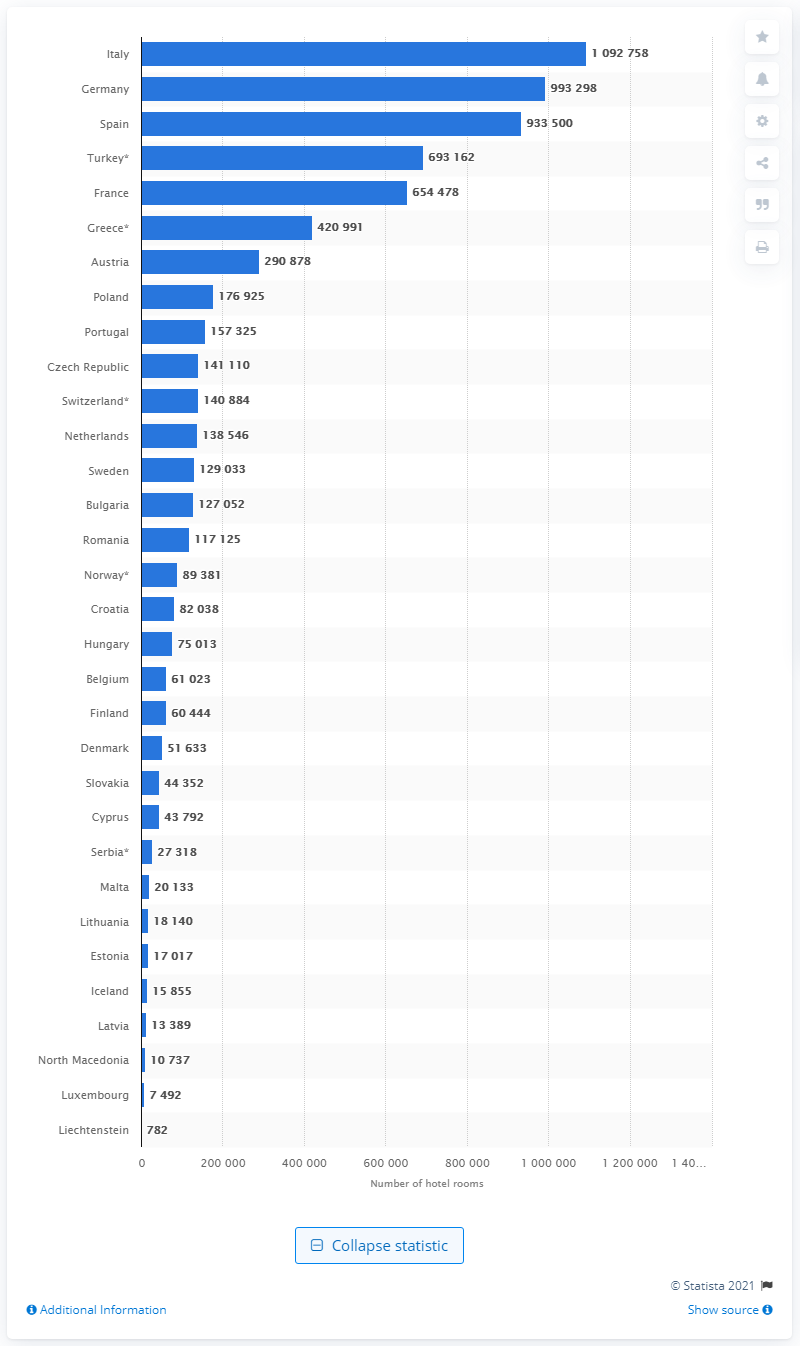Point out several critical features in this image. According to data from 2019, Italy is the country that has registered more than one million hotel bedrooms. 